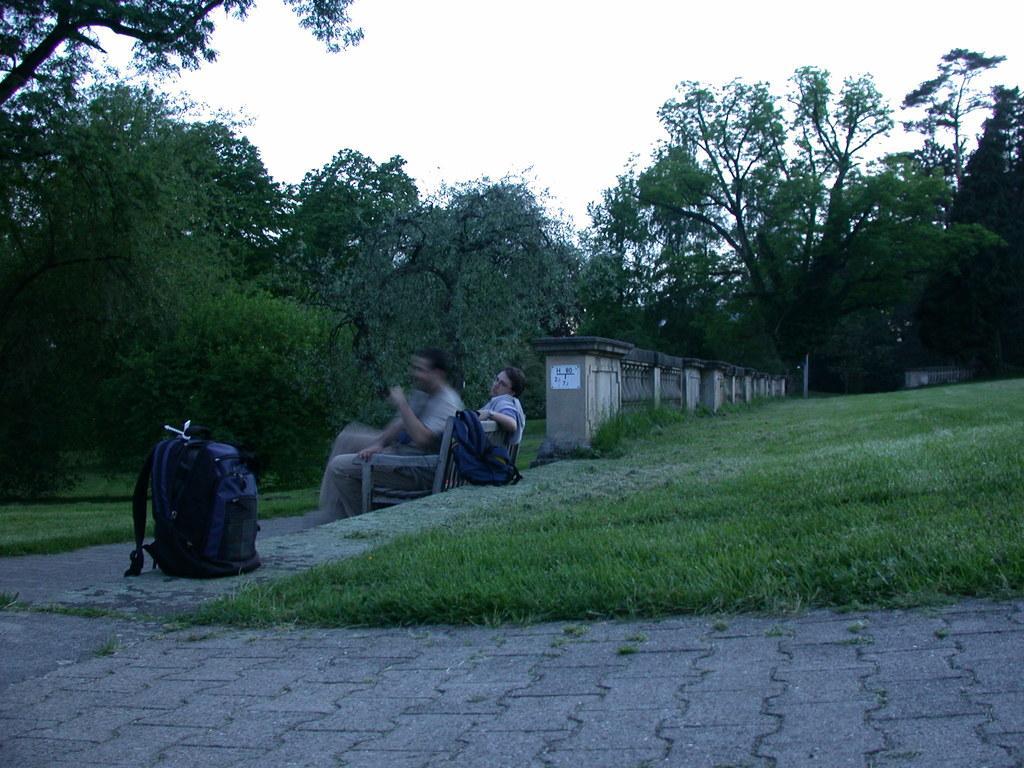Please provide a concise description of this image. Two men are sitting on the bench there are trees around them and in the right its a grass there is a bag in the left. 